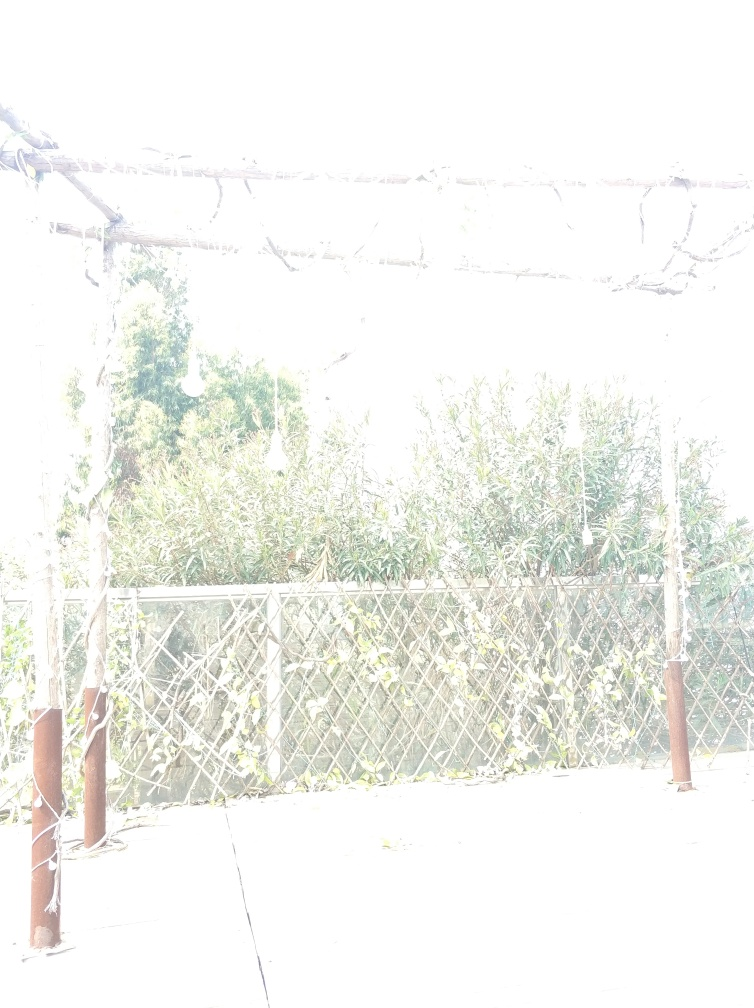Is the overall sharpness of the image good?
 No 